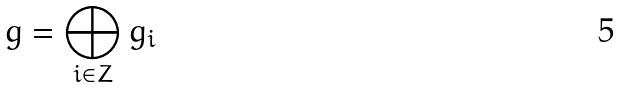<formula> <loc_0><loc_0><loc_500><loc_500>g = \bigoplus _ { i \in Z } g _ { i }</formula> 